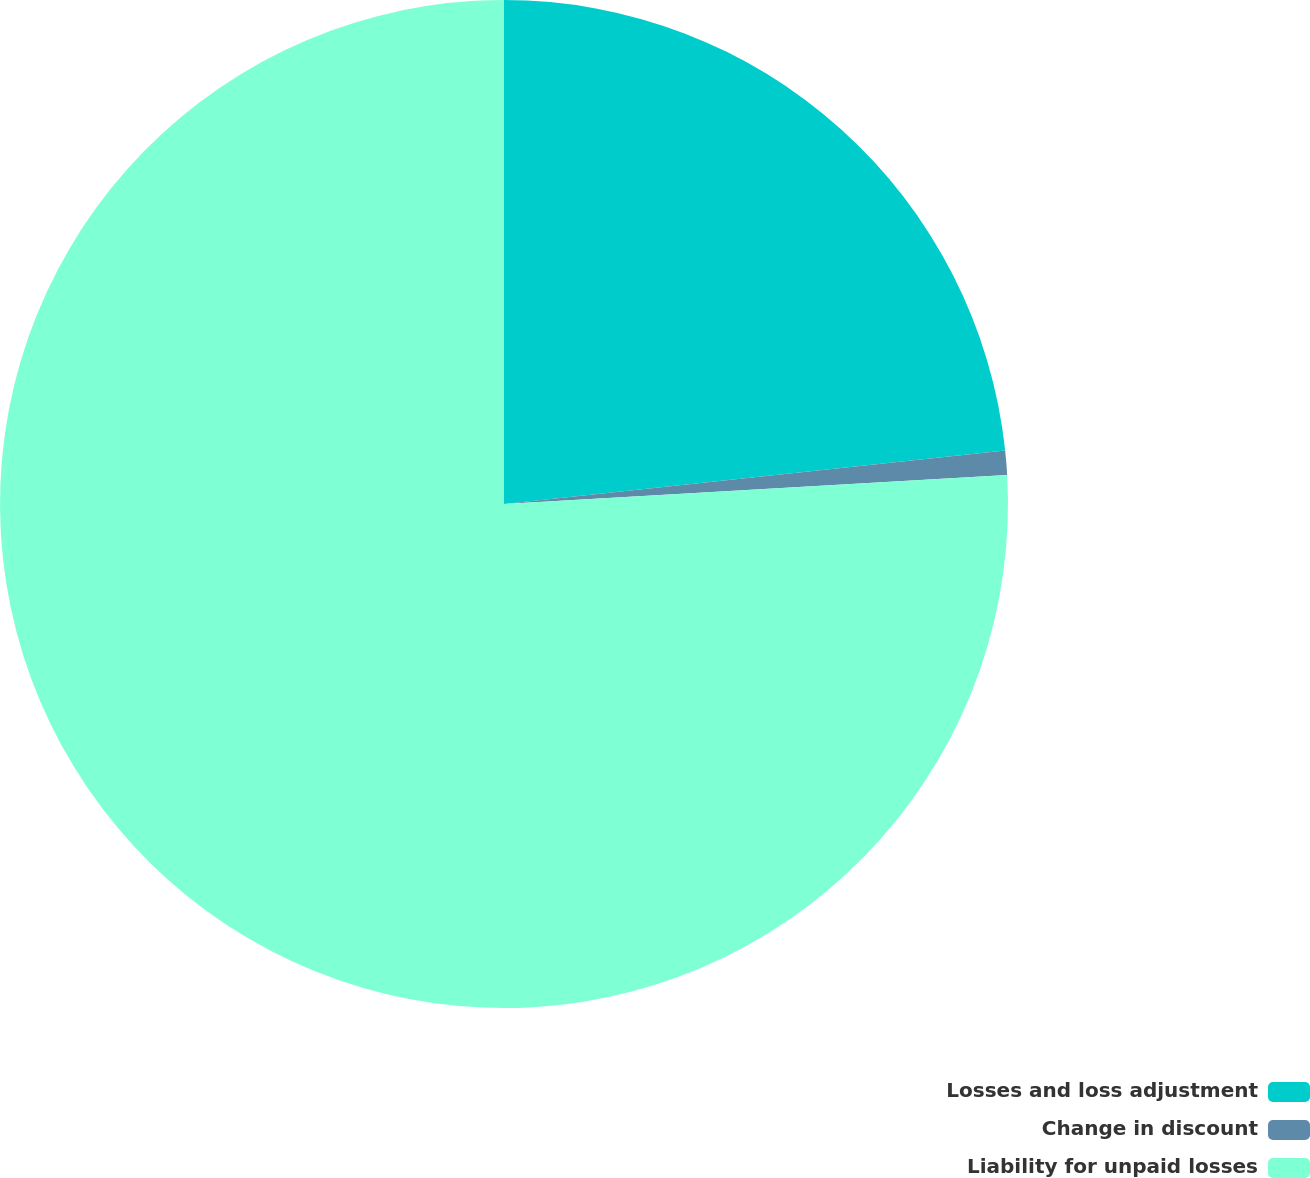Convert chart. <chart><loc_0><loc_0><loc_500><loc_500><pie_chart><fcel>Losses and loss adjustment<fcel>Change in discount<fcel>Liability for unpaid losses<nl><fcel>23.31%<fcel>0.77%<fcel>75.92%<nl></chart> 